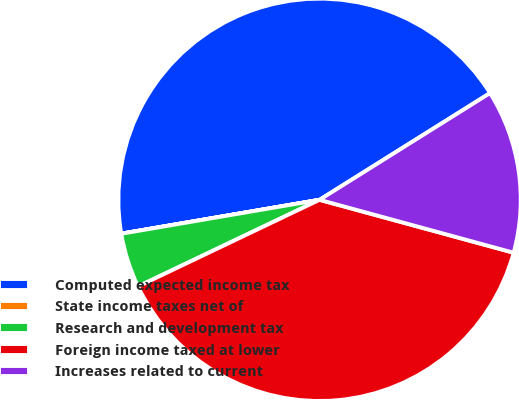Convert chart to OTSL. <chart><loc_0><loc_0><loc_500><loc_500><pie_chart><fcel>Computed expected income tax<fcel>State income taxes net of<fcel>Research and development tax<fcel>Foreign income taxed at lower<fcel>Increases related to current<nl><fcel>43.79%<fcel>0.01%<fcel>4.39%<fcel>38.68%<fcel>13.14%<nl></chart> 